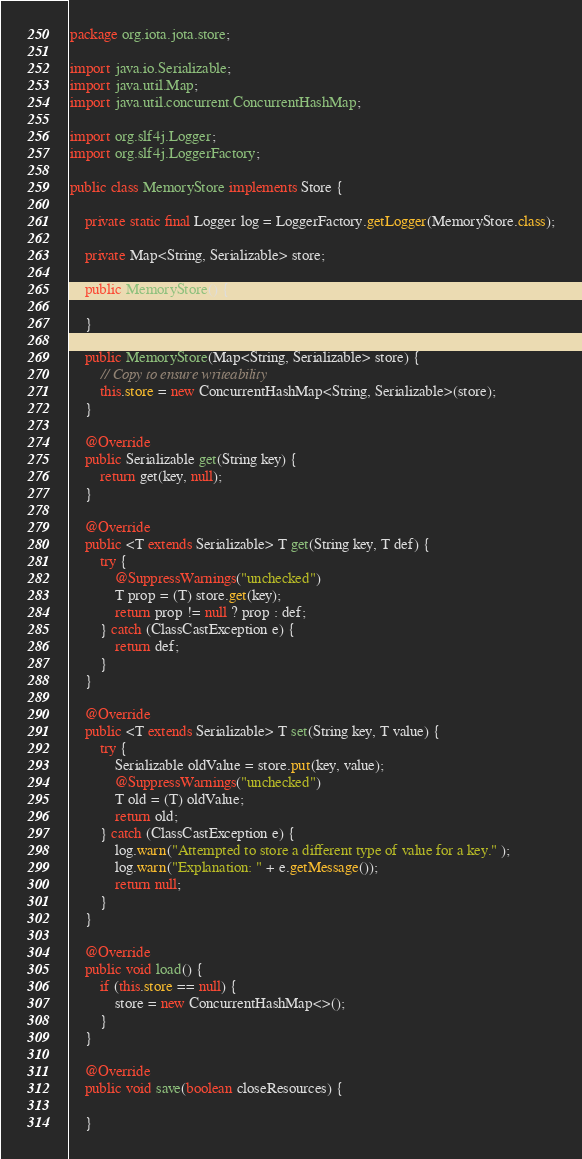Convert code to text. <code><loc_0><loc_0><loc_500><loc_500><_Java_>package org.iota.jota.store;

import java.io.Serializable;
import java.util.Map;
import java.util.concurrent.ConcurrentHashMap;

import org.slf4j.Logger;
import org.slf4j.LoggerFactory;

public class MemoryStore implements Store {

    private static final Logger log = LoggerFactory.getLogger(MemoryStore.class);
    
    private Map<String, Serializable> store;
    
    public MemoryStore() {
        
    }
    
    public MemoryStore(Map<String, Serializable> store) {
        // Copy to ensure writeability
        this.store = new ConcurrentHashMap<String, Serializable>(store);
    }

    @Override
    public Serializable get(String key) {
        return get(key, null);
    }

    @Override
    public <T extends Serializable> T get(String key, T def) {
        try {
            @SuppressWarnings("unchecked")
            T prop = (T) store.get(key);
            return prop != null ? prop : def;
        } catch (ClassCastException e) {
            return def;
        }
    }
    
    @Override
    public <T extends Serializable> T set(String key, T value) {
        try {
            Serializable oldValue = store.put(key, value);
            @SuppressWarnings("unchecked")
            T old = (T) oldValue;
            return old;
        } catch (ClassCastException e) {
            log.warn("Attempted to store a different type of value for a key." );
            log.warn("Explanation: " + e.getMessage());
            return null;
        }
    }
    
    @Override
    public void load() {
        if (this.store == null) {
            store = new ConcurrentHashMap<>();
        }
    }

    @Override
    public void save(boolean closeResources) {
        
    }</code> 